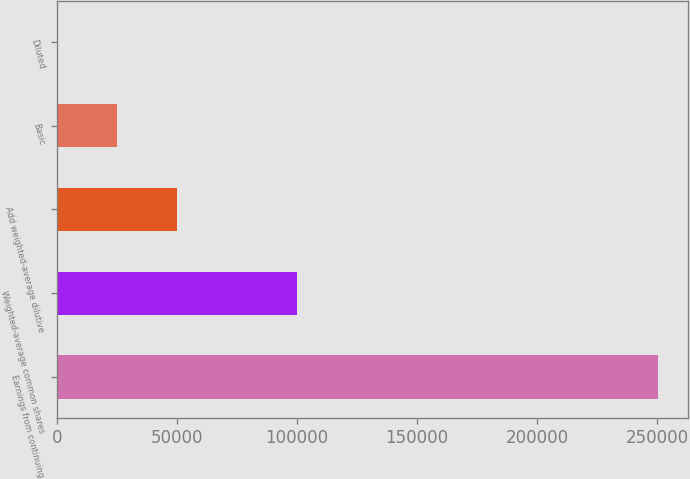Convert chart. <chart><loc_0><loc_0><loc_500><loc_500><bar_chart><fcel>Earnings from continuing<fcel>Weighted-average common shares<fcel>Add weighted-average dilutive<fcel>Basic<fcel>Diluted<nl><fcel>250258<fcel>100105<fcel>50054.5<fcel>25029<fcel>3.61<nl></chart> 